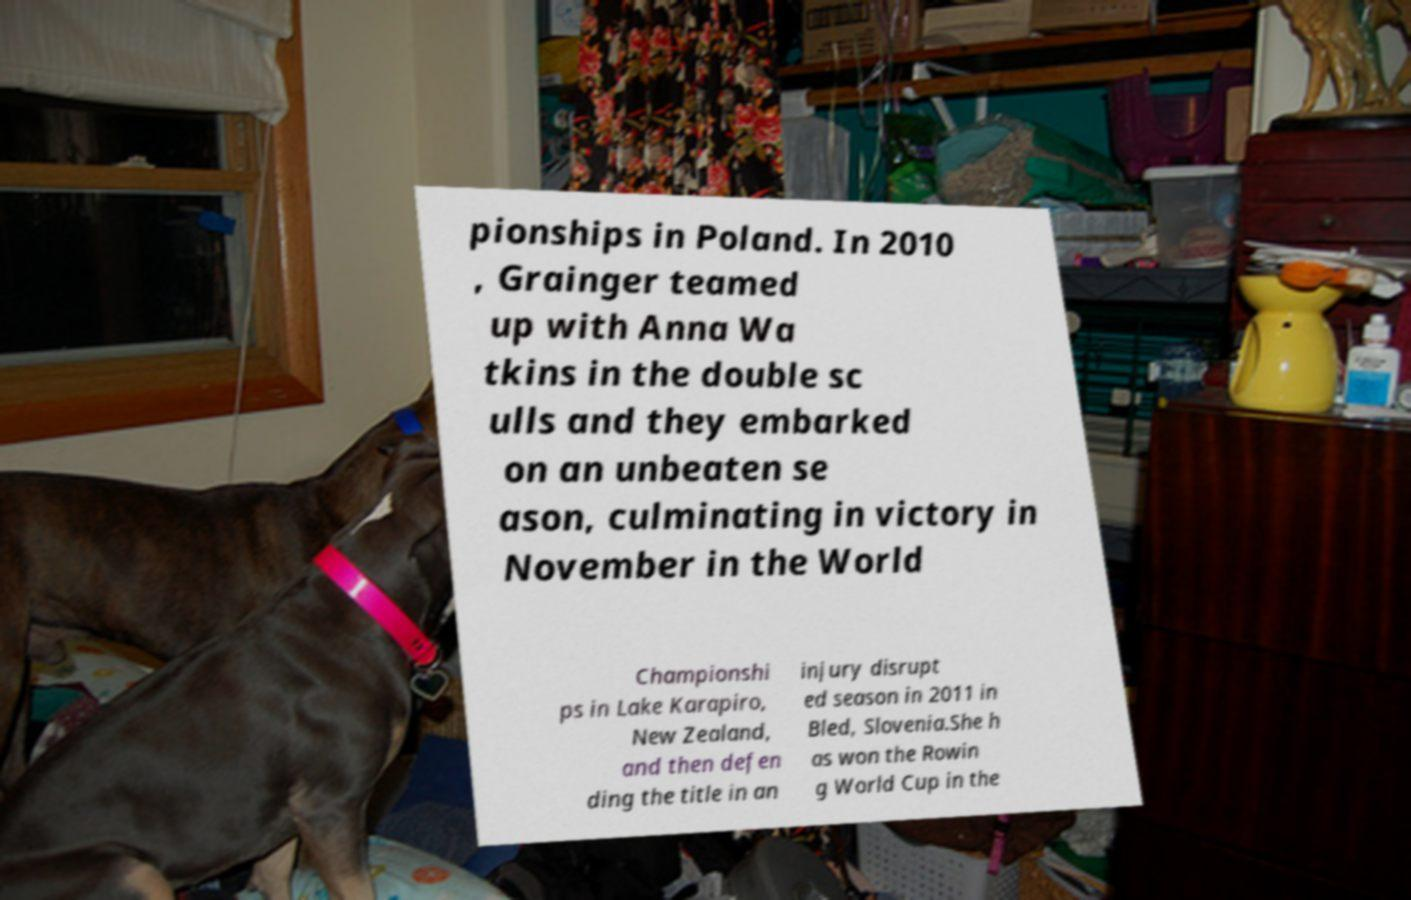I need the written content from this picture converted into text. Can you do that? pionships in Poland. In 2010 , Grainger teamed up with Anna Wa tkins in the double sc ulls and they embarked on an unbeaten se ason, culminating in victory in November in the World Championshi ps in Lake Karapiro, New Zealand, and then defen ding the title in an injury disrupt ed season in 2011 in Bled, Slovenia.She h as won the Rowin g World Cup in the 